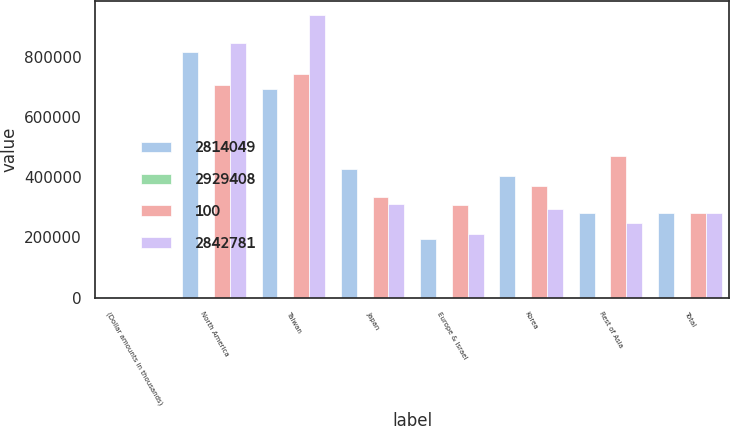Convert chart. <chart><loc_0><loc_0><loc_500><loc_500><stacked_bar_chart><ecel><fcel>(Dollar amounts in thousands)<fcel>North America<fcel>Taiwan<fcel>Japan<fcel>Europe & Israel<fcel>Korea<fcel>Rest of Asia<fcel>Total<nl><fcel>2.81405e+06<fcel>2015<fcel>815914<fcel>691482<fcel>426963<fcel>194670<fcel>405320<fcel>279700<fcel>279700<nl><fcel>2.92941e+06<fcel>2015<fcel>29<fcel>25<fcel>15<fcel>7<fcel>14<fcel>10<fcel>100<nl><fcel>100<fcel>2014<fcel>705159<fcel>741470<fcel>334653<fcel>306779<fcel>371139<fcel>470208<fcel>279700<nl><fcel>2.84278e+06<fcel>2013<fcel>846125<fcel>936445<fcel>310204<fcel>211121<fcel>292724<fcel>246162<fcel>279700<nl></chart> 